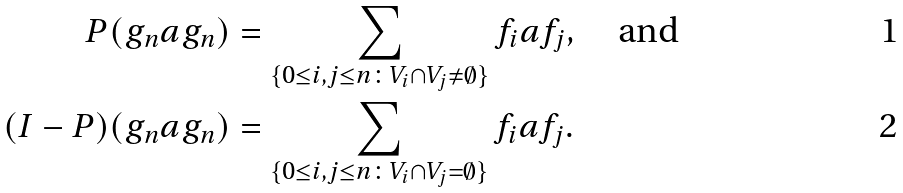<formula> <loc_0><loc_0><loc_500><loc_500>P ( g _ { n } a g _ { n } ) & = \sum _ { \{ 0 \leq i , j \leq n \colon V _ { i } \cap V _ { j } \neq \emptyset \} } f _ { i } a f _ { j } , \quad \text {and} \\ ( I - P ) ( g _ { n } a g _ { n } ) & = \sum _ { \{ 0 \leq i , j \leq n \colon V _ { i } \cap V _ { j } = \emptyset \} } f _ { i } a f _ { j } .</formula> 